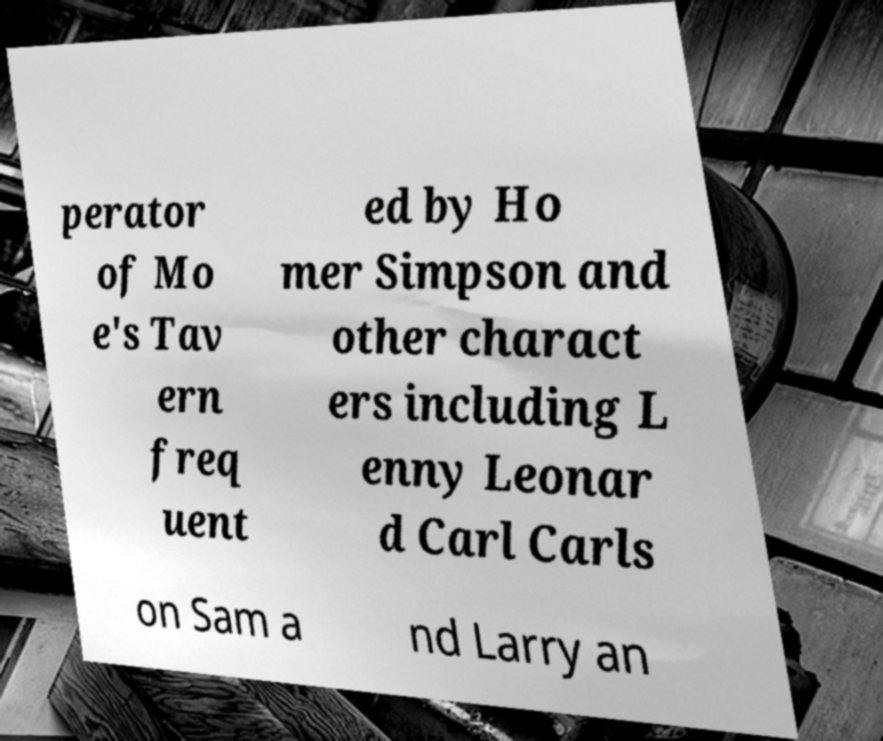Could you assist in decoding the text presented in this image and type it out clearly? perator of Mo e's Tav ern freq uent ed by Ho mer Simpson and other charact ers including L enny Leonar d Carl Carls on Sam a nd Larry an 